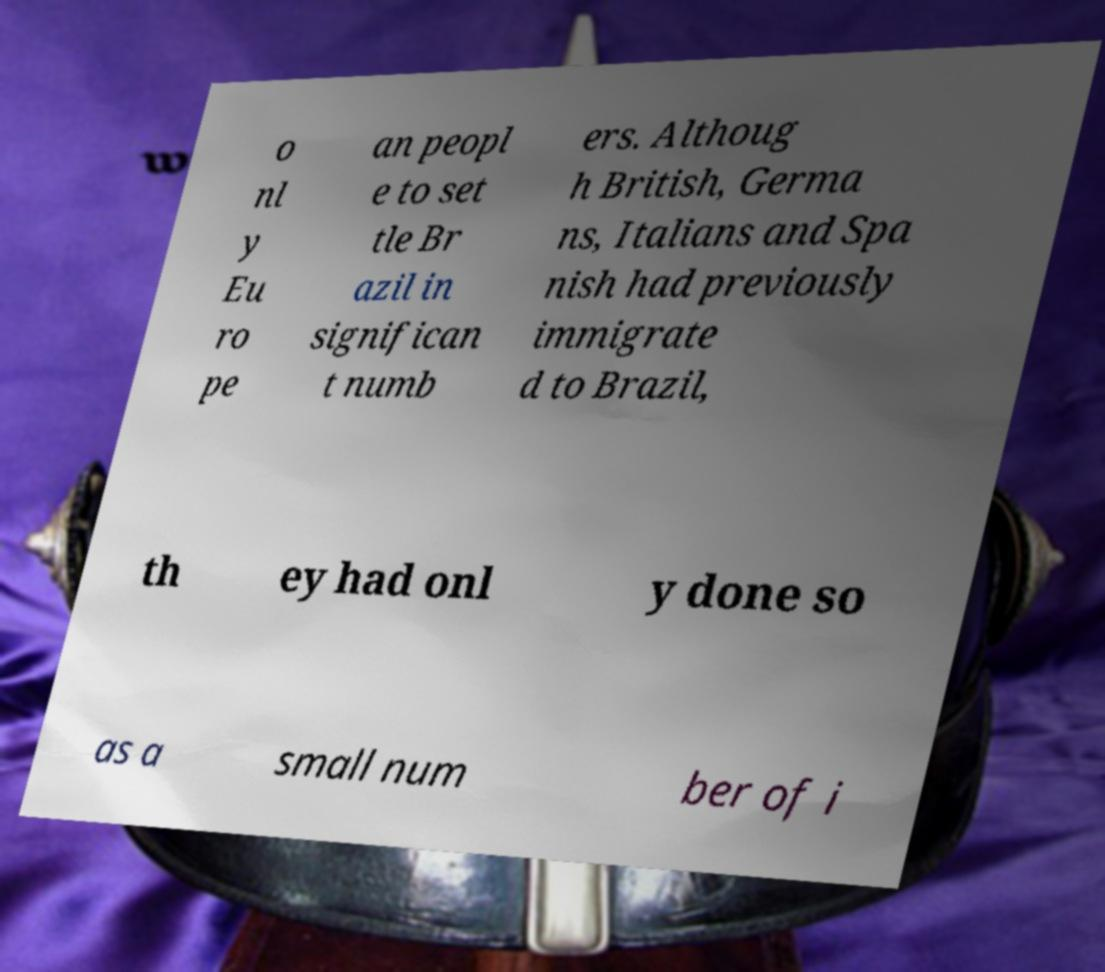Can you read and provide the text displayed in the image?This photo seems to have some interesting text. Can you extract and type it out for me? o nl y Eu ro pe an peopl e to set tle Br azil in significan t numb ers. Althoug h British, Germa ns, Italians and Spa nish had previously immigrate d to Brazil, th ey had onl y done so as a small num ber of i 